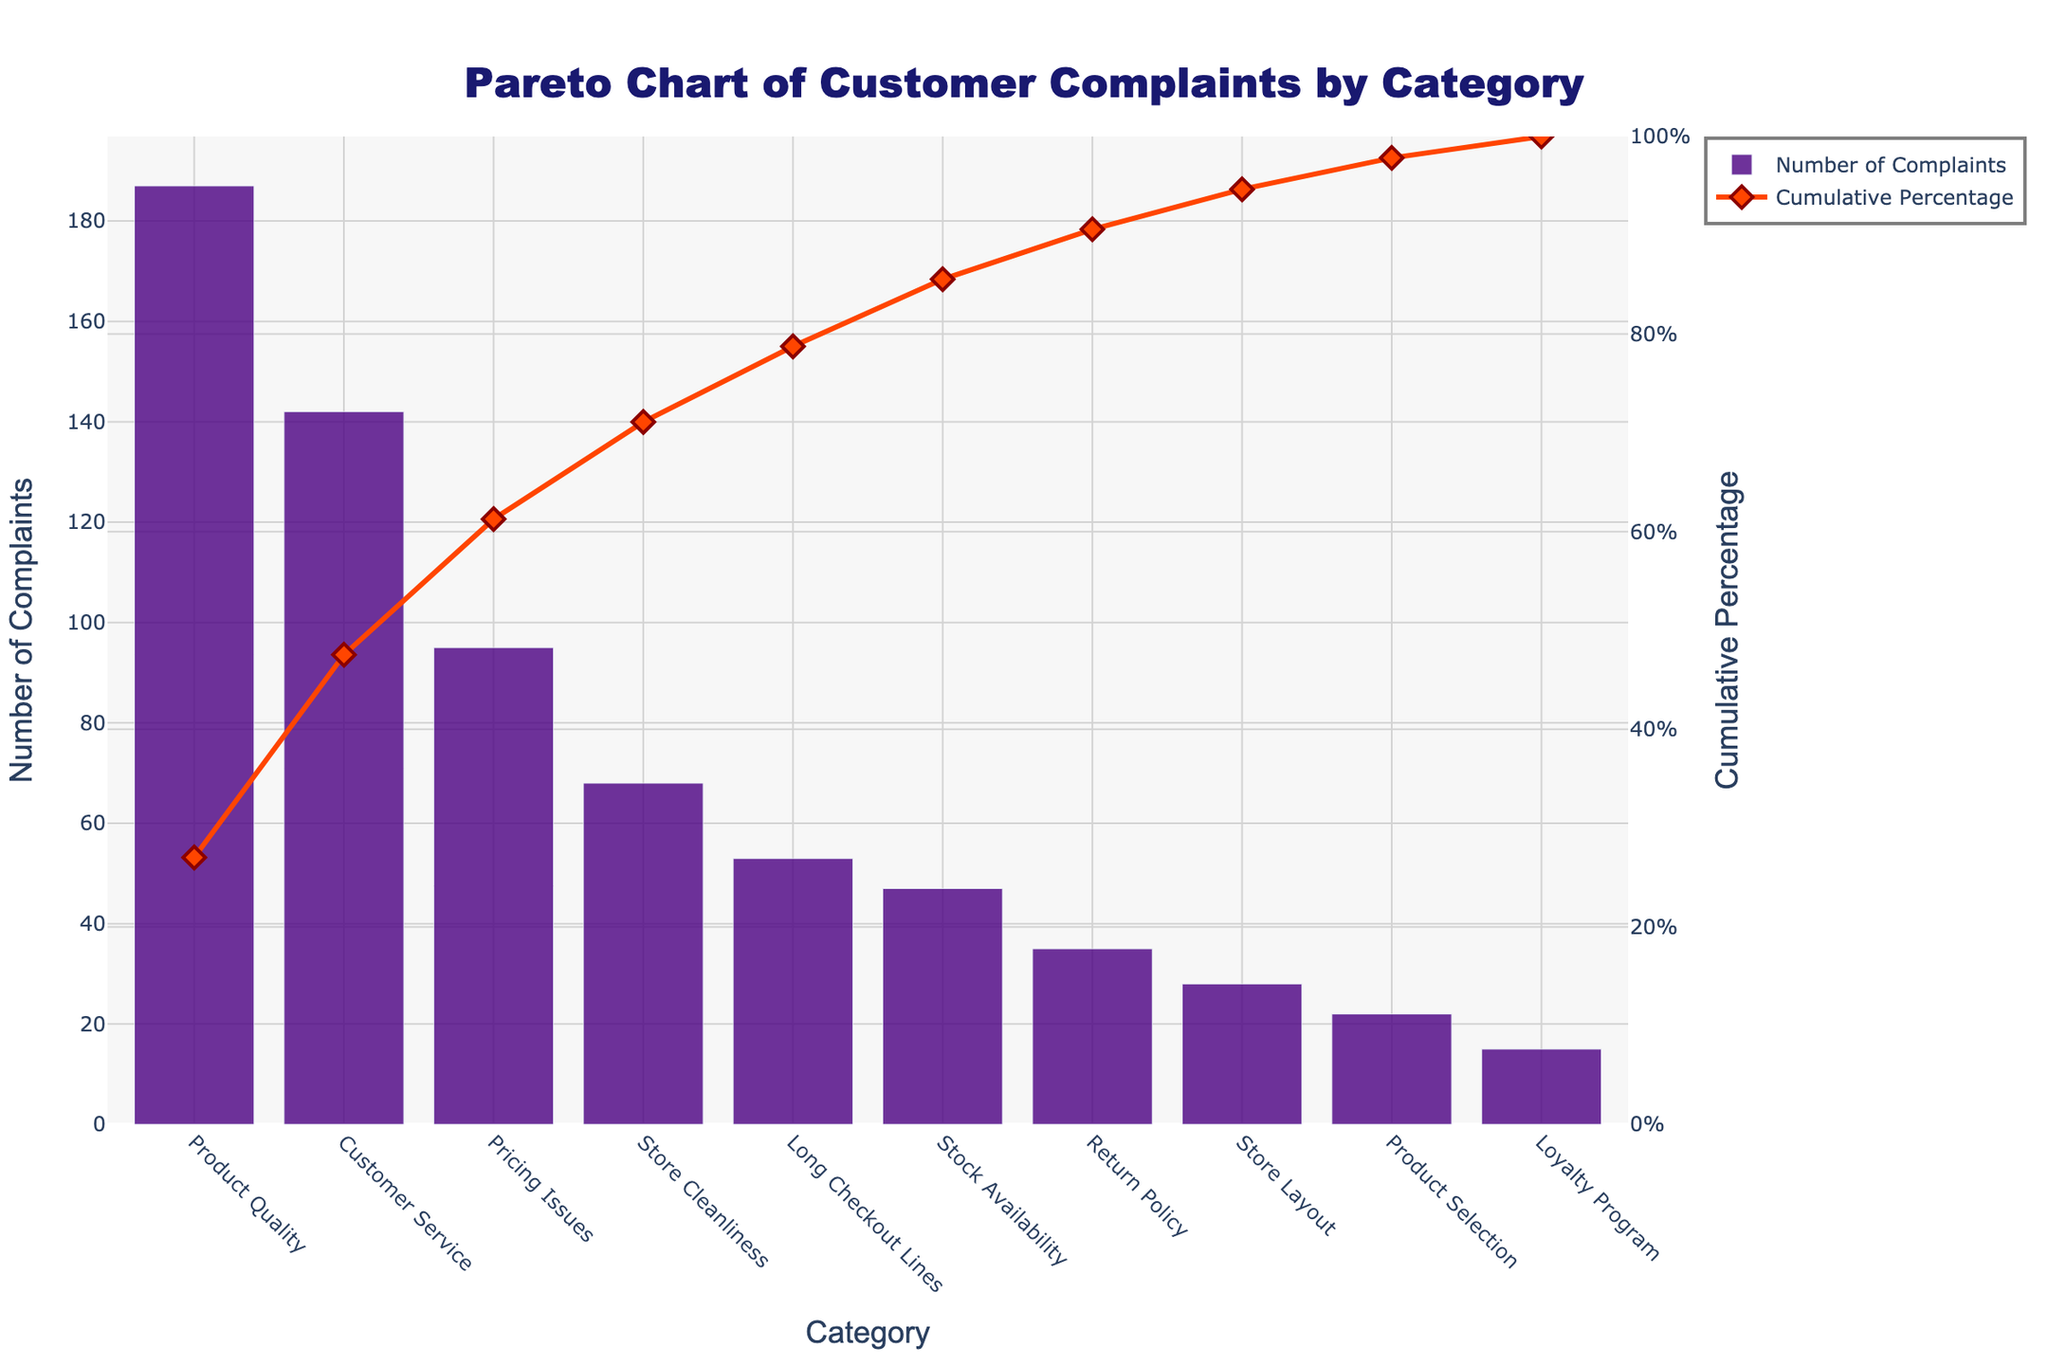what is the title of the figure? The title of the figure is located at the top, centered, and bold and reads “Pareto Chart of Customer Complaints by Category.”
Answer: Pareto Chart of Customer Complaints by Category what is the color of the bars representing the number of complaints? The bars representing the number of complaints are colored in a shade of purple.
Answer: Purple what category has the highest number of complaints? The highest bar represents the category with the most complaints, which is “Product Quality.”
Answer: Product Quality which category has the lowest number of complaints? The smallest bar indicates the category with the fewest complaints, which is for the "Loyalty Program."
Answer: Loyalty Program what is the cumulative percentage of complaints for "Customer Service"? To find the cumulative percentage for "Customer Service," we look at the cumulative line value positioned above the "Customer Service" bar, which shows approximately 58%.
Answer: Approximately 58% how many complaints are there for categories that make up at least 80% of the total complaints? To determine this, check where the cumulative percentage line crosses 80%, then sum the complaints for all categories up to that point. The categories are Product Quality, Customer Service, Pricing Issues, and Store Cleanliness, which add up to (187 + 142 + 95 + 68) = 492 complaints.
Answer: 492 complaints which categories collectively account for approximately the top 50% of complaints? Look for where the cumulative percentage line is around 50%. The categories up to that point are "Product Quality" and "Customer Service."
Answer: Product Quality and Customer Service how much higher is the number of complaints for "Product Quality" compared to "Stock Availability"? Subtract the number of complaints for "Stock Availability" (47) from "Product Quality" (187). The difference is 187 - 47 = 140 complaints.
Answer: 140 complaints in terms of visual elements, what denotes the cumulative percentage? The cumulative percentage is indicated by the orange line and diamond markers plotted on the right y-axis.
Answer: Orange line and diamond markers what percentage of the total complaints are due to "Pricing Issues" and "Store Cleanliness" combined? Add the number of complaints for "Pricing Issues" (95) and "Store Cleanliness" (68) and then divide by the total number of complaints, then multiply by 100 to get the percentage: (95 + 68) / 692 * 100 = 23.49%.
Answer: 23.49% 